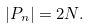<formula> <loc_0><loc_0><loc_500><loc_500>| P _ { n } | = 2 N .</formula> 